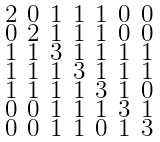Convert formula to latex. <formula><loc_0><loc_0><loc_500><loc_500>\begin{smallmatrix} 2 & 0 & 1 & 1 & 1 & 0 & 0 \\ 0 & 2 & 1 & 1 & 1 & 0 & 0 \\ 1 & 1 & 3 & 1 & 1 & 1 & 1 \\ 1 & 1 & 1 & 3 & 1 & 1 & 1 \\ 1 & 1 & 1 & 1 & 3 & 1 & 0 \\ 0 & 0 & 1 & 1 & 1 & 3 & 1 \\ 0 & 0 & 1 & 1 & 0 & 1 & 3 \end{smallmatrix}</formula> 